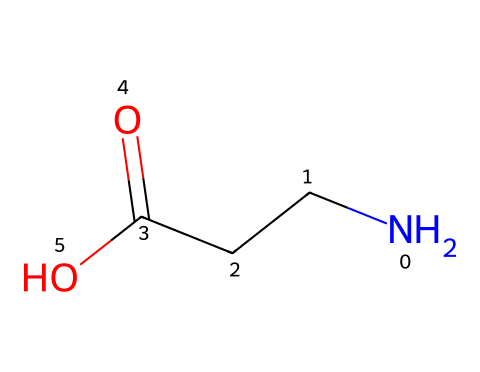What is the primary functional group present in beta-alanine? The SMILES representation shows a carboxylic acid group (-COOH) at the end of the structure. This indicates that beta-alanine contains a carboxylic acid functional group.
Answer: carboxylic acid How many carbon atoms are in beta-alanine? Analyzing the SMILES, we see "NCCC", which indicates there are three carbon atoms present.
Answer: three What is the total number of hydrogen atoms in beta-alanine? In the SMILES, the structure contains three carbon atoms and one nitrogen atom with a carboxylic acid (-COOH) which contributes one hydrogen atom, resulting in a total of 7 hydrogen atoms from the full structural consideration.
Answer: seven What type of molecule is beta-alanine classified as? Given its structure, which includes an amino group (-NH2) adjacent to the carboxylic acid, beta-alanine is classified as an amino acid.
Answer: amino acid Is beta-alanine considered a zwitterion at physiological pH? The structure shows both a positively charged amino group and a negatively charged carboxylate group at physiological pH, indicating that beta-alanine exists as a zwitterion.
Answer: yes What charge does beta-alanine carry at a pH above its isoelectric point? At pH levels above its isoelectric point, the carboxylic acid will be deprotonated while the amino group remains protonated, resulting in a net negative charge on the molecule.
Answer: negative 